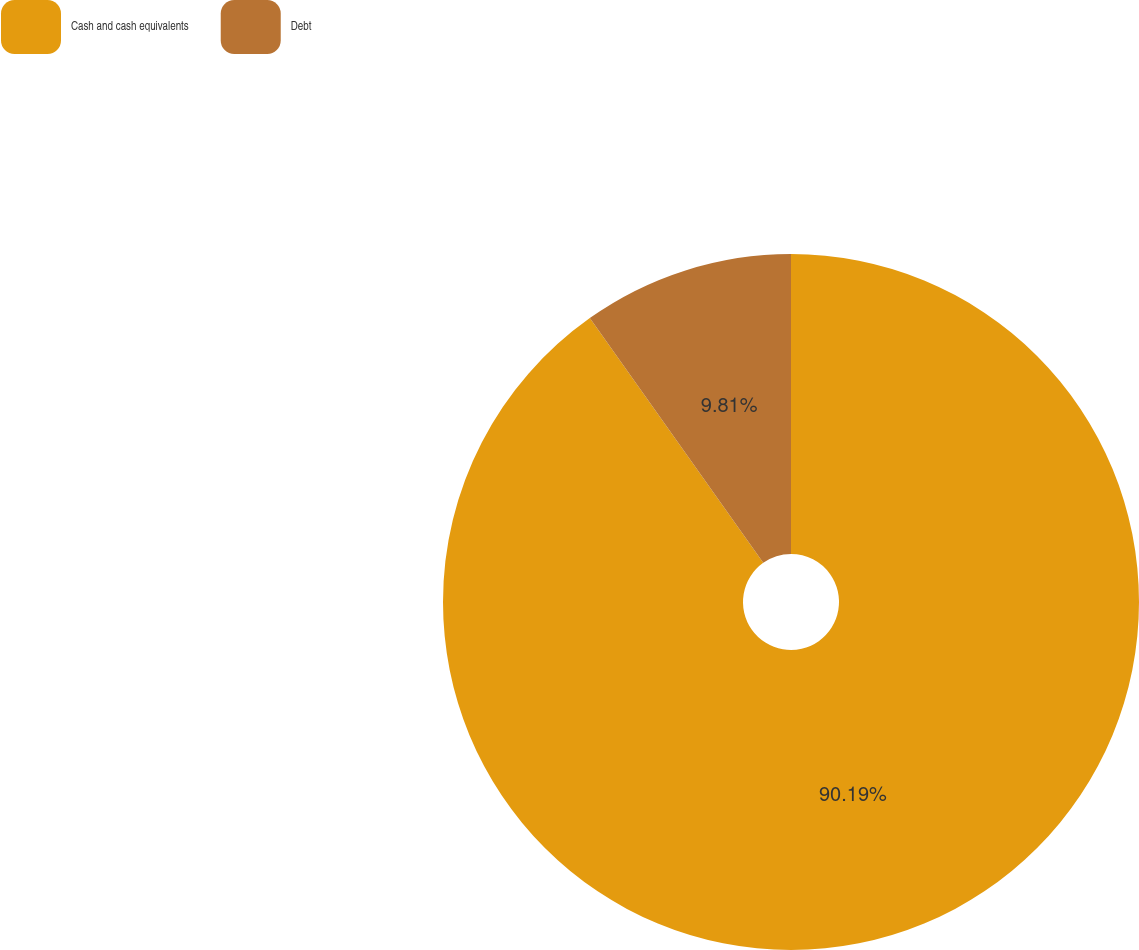<chart> <loc_0><loc_0><loc_500><loc_500><pie_chart><fcel>Cash and cash equivalents<fcel>Debt<nl><fcel>90.19%<fcel>9.81%<nl></chart> 